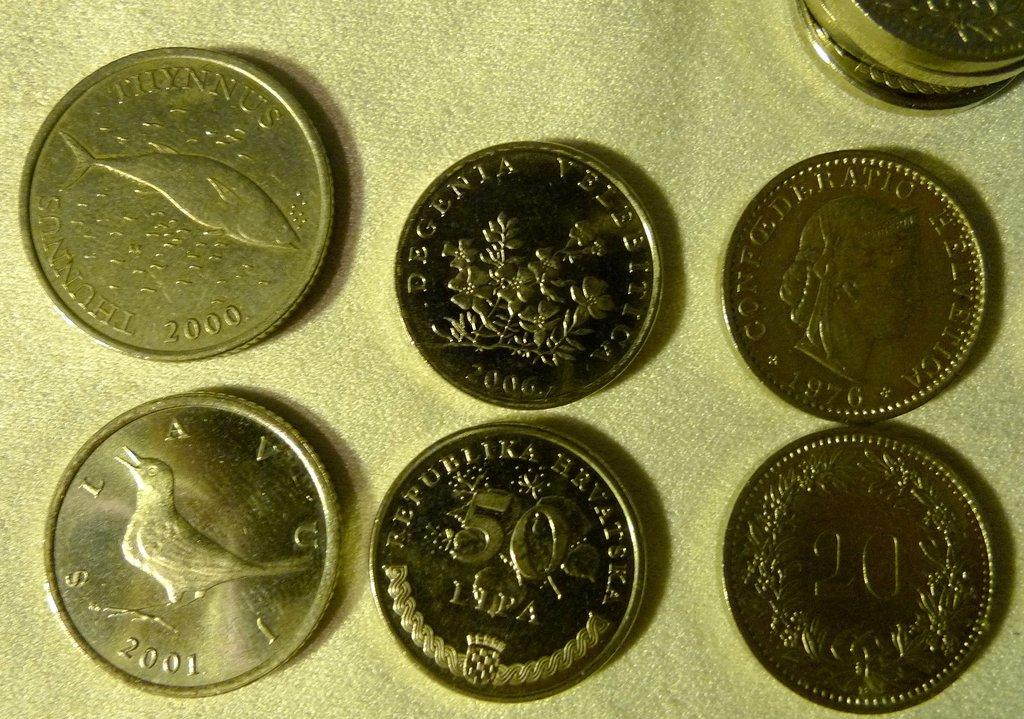<image>
Summarize the visual content of the image. An assortment of vintage coins, one of which was printed in 2000. 